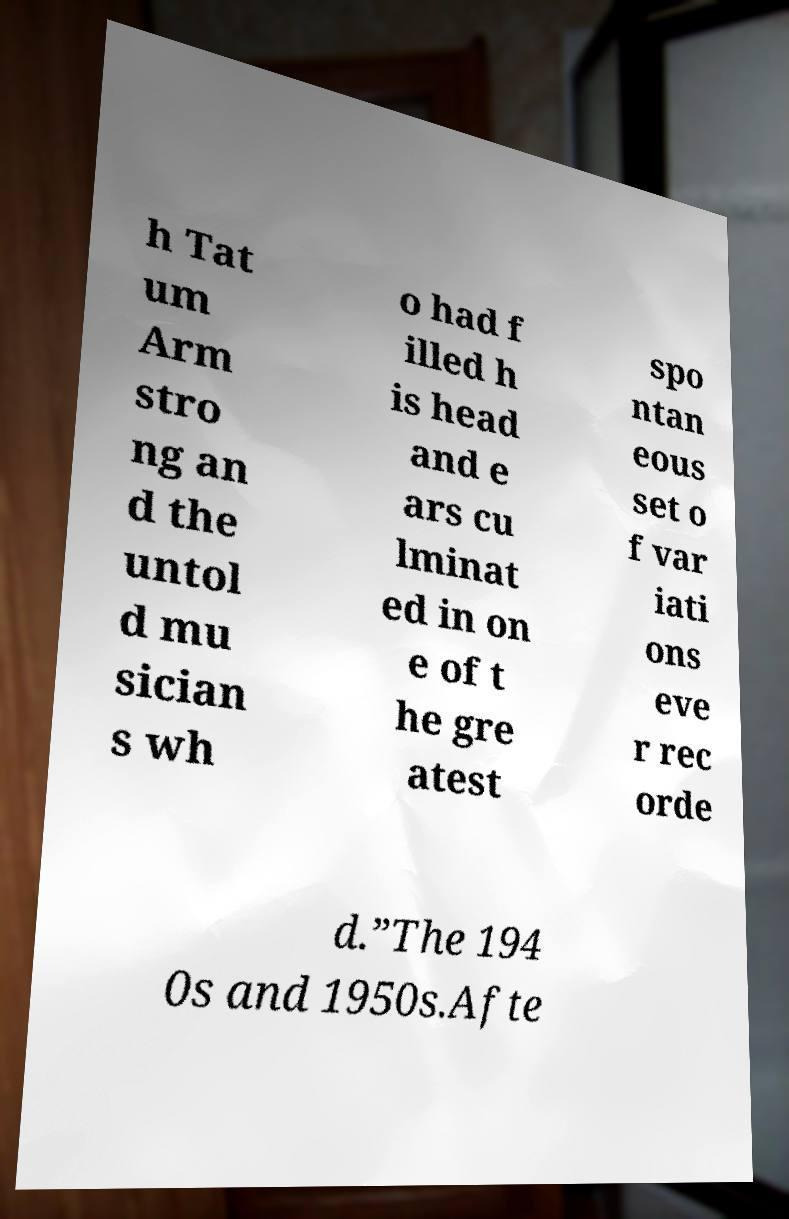Please identify and transcribe the text found in this image. h Tat um Arm stro ng an d the untol d mu sician s wh o had f illed h is head and e ars cu lminat ed in on e of t he gre atest spo ntan eous set o f var iati ons eve r rec orde d.”The 194 0s and 1950s.Afte 